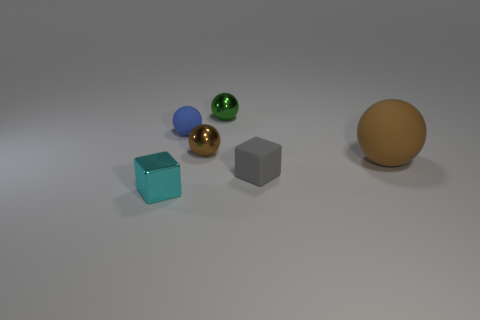Are there any repeating shapes or colors among the objects? Yes, there are repeating shapes within the objects. There are two spheres, two cubes, and one cuboid. Regarding color, two objects share a turquoise hue—a small sphere and a larger cube. Which of the objects have a texture or finish that stands out? The golden-brown sphere stands out due to its matte finish, contrasting with the metallic sheen on both the small turquoise sphere and the gold-colored sphere. The cubes and cuboid have what appears to be a smooth and slightly reflective surface. 